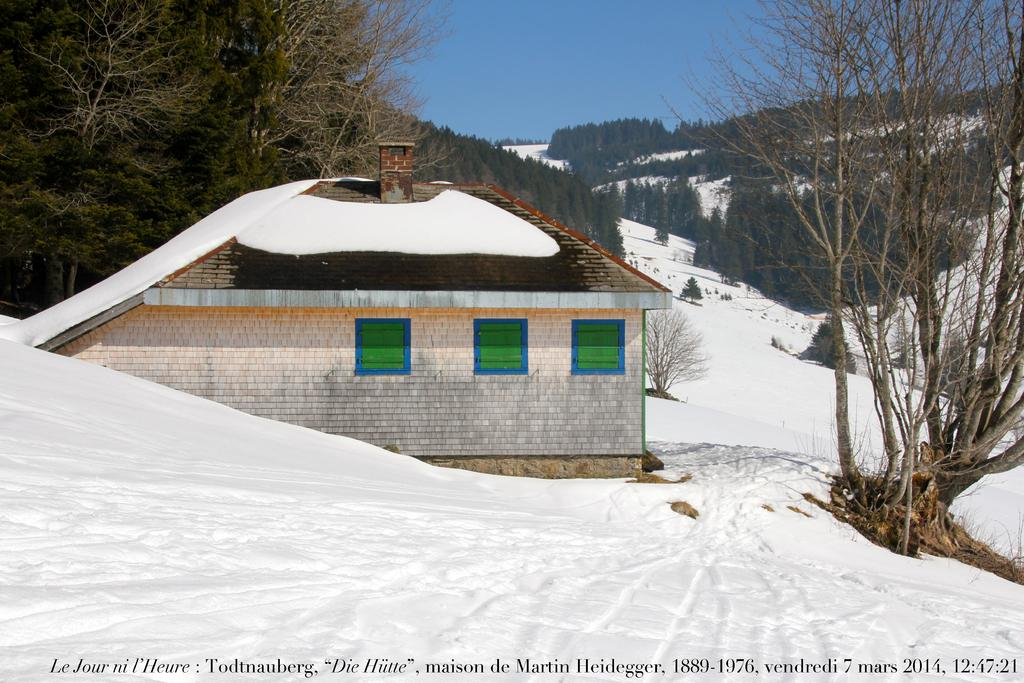What structures are located in the front of the image? There are buildings in the front of the image. What type of vegetation is behind the buildings? Trees are present behind the buildings. How would you describe the landscape in the image? The image is set on a snowy landscape. What part of the natural environment is visible above the landscape? The sky is visible above the landscape. Can you see any fish swimming in the snowy landscape? There are no fish visible in the image, as it is set on a snowy landscape and fish typically live in water. 